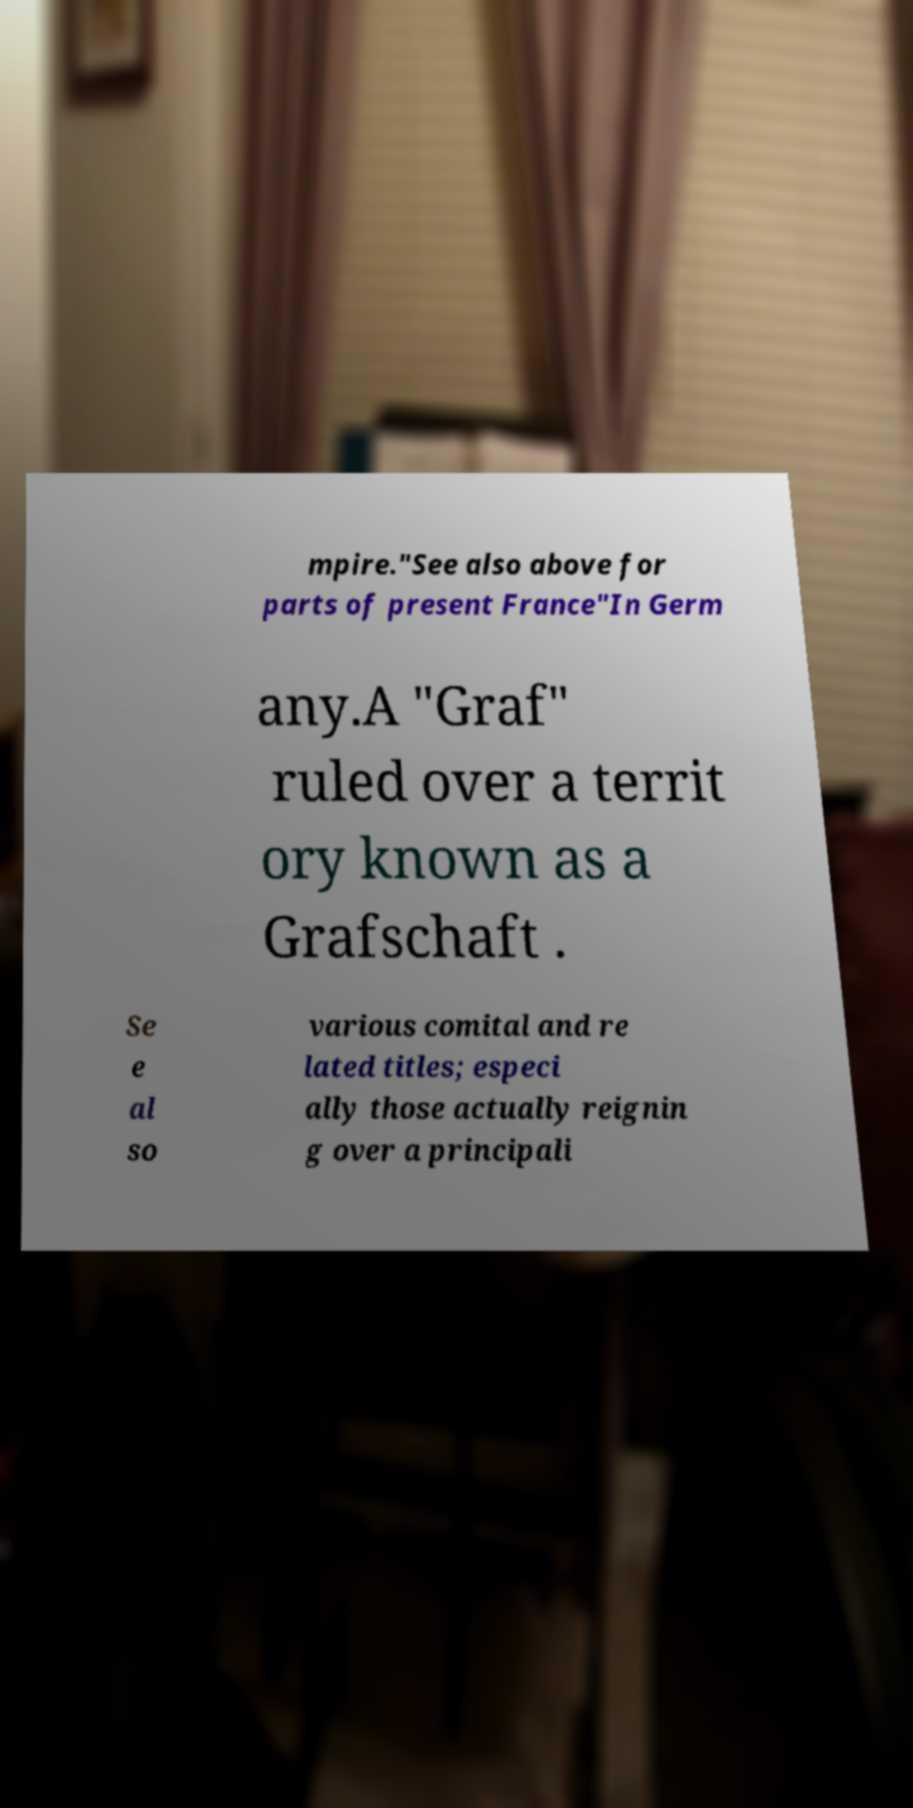Please read and relay the text visible in this image. What does it say? mpire."See also above for parts of present France"In Germ any.A "Graf" ruled over a territ ory known as a Grafschaft . Se e al so various comital and re lated titles; especi ally those actually reignin g over a principali 